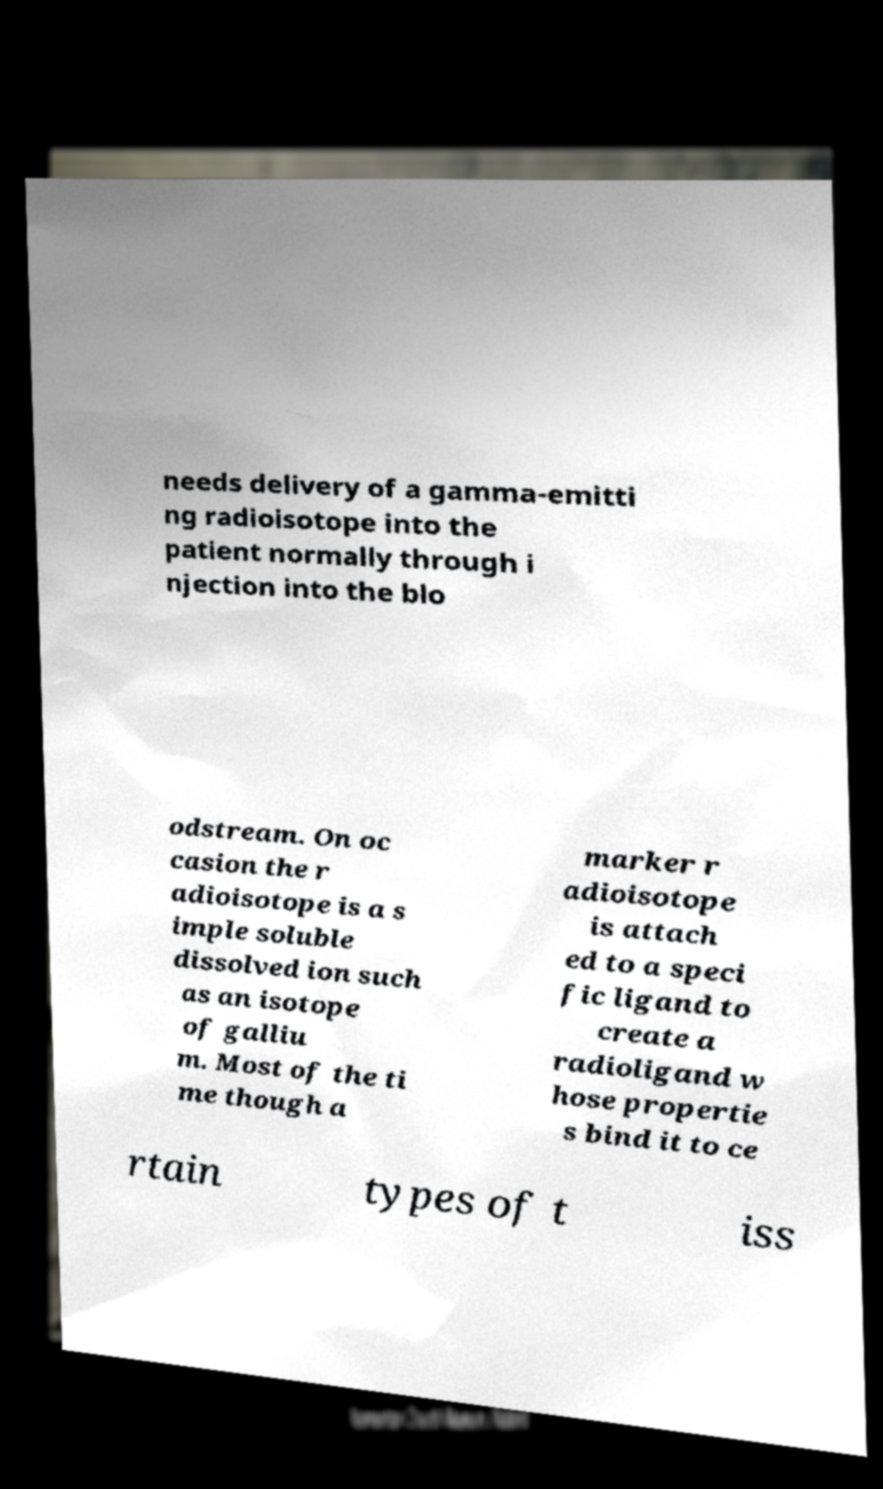What messages or text are displayed in this image? I need them in a readable, typed format. needs delivery of a gamma-emitti ng radioisotope into the patient normally through i njection into the blo odstream. On oc casion the r adioisotope is a s imple soluble dissolved ion such as an isotope of galliu m. Most of the ti me though a marker r adioisotope is attach ed to a speci fic ligand to create a radioligand w hose propertie s bind it to ce rtain types of t iss 